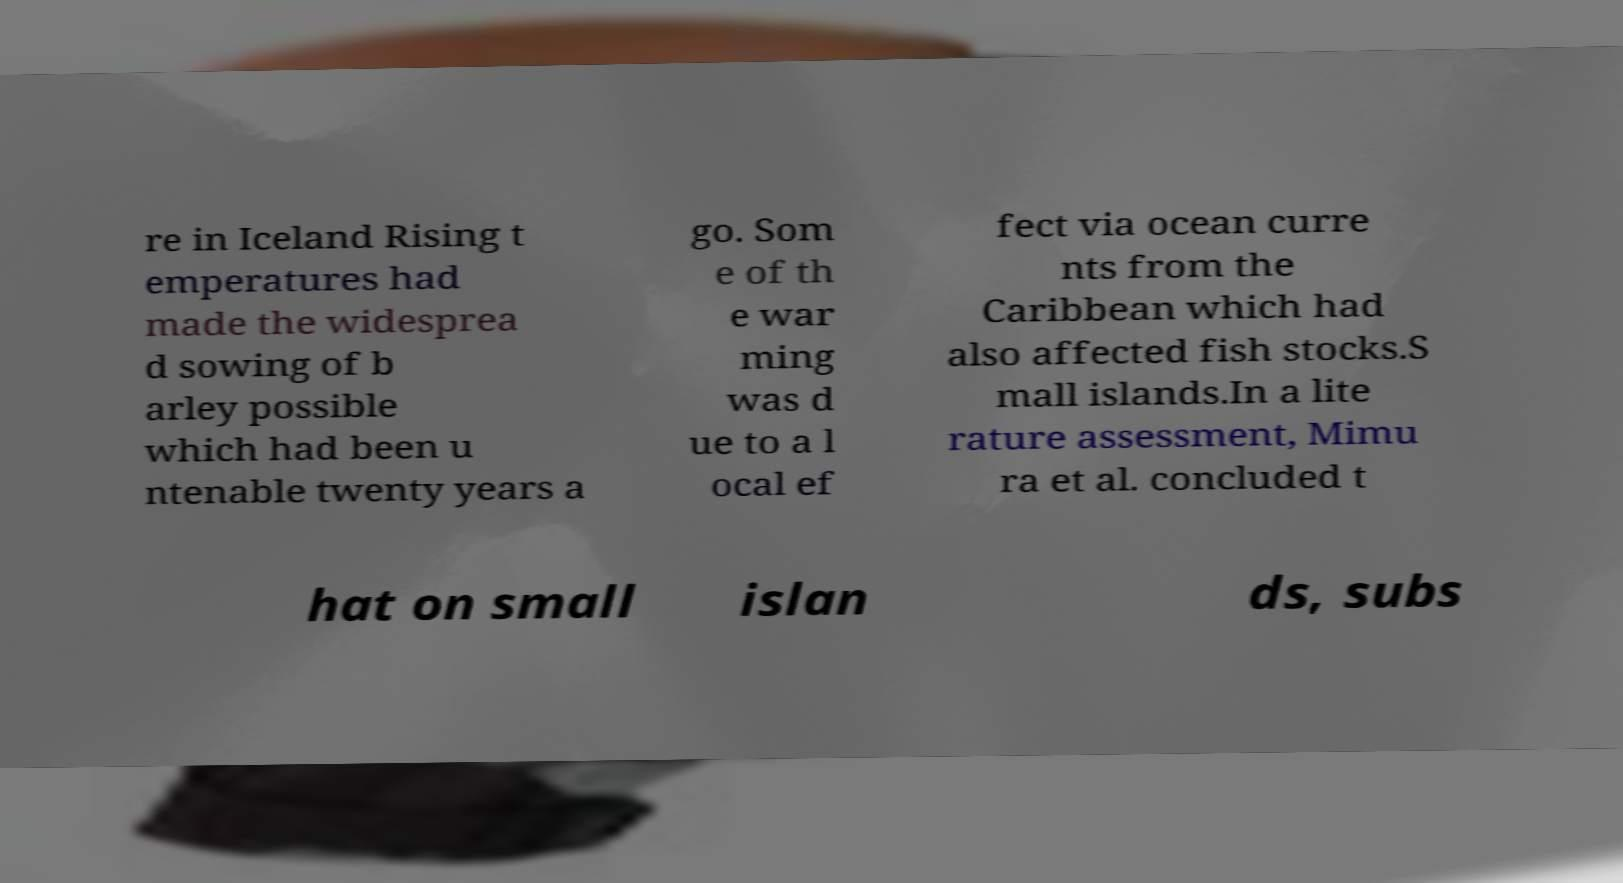Please identify and transcribe the text found in this image. re in Iceland Rising t emperatures had made the widesprea d sowing of b arley possible which had been u ntenable twenty years a go. Som e of th e war ming was d ue to a l ocal ef fect via ocean curre nts from the Caribbean which had also affected fish stocks.S mall islands.In a lite rature assessment, Mimu ra et al. concluded t hat on small islan ds, subs 